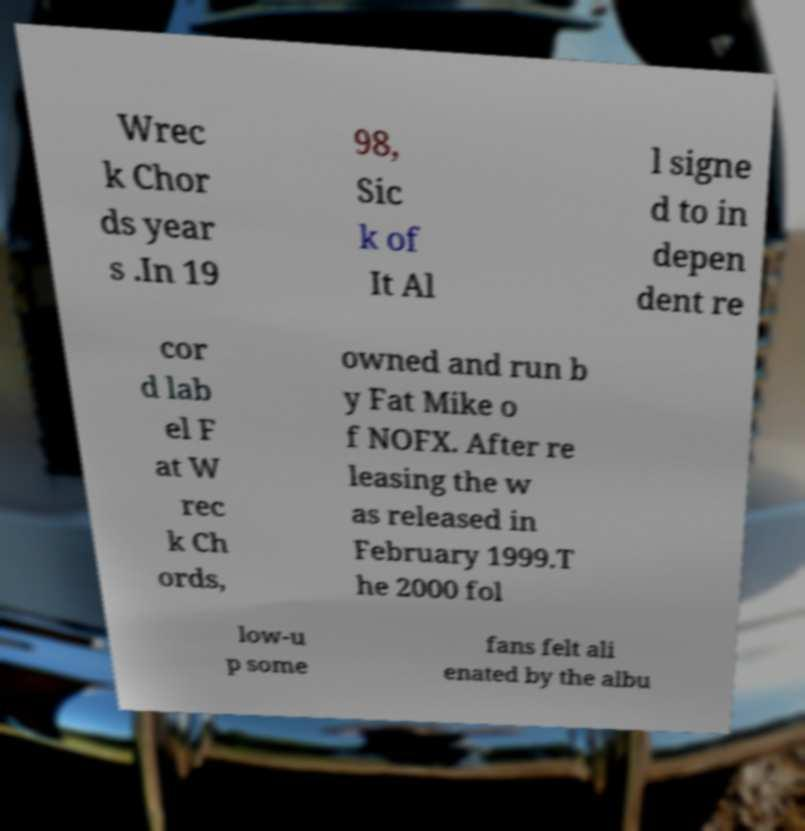Please identify and transcribe the text found in this image. Wrec k Chor ds year s .In 19 98, Sic k of It Al l signe d to in depen dent re cor d lab el F at W rec k Ch ords, owned and run b y Fat Mike o f NOFX. After re leasing the w as released in February 1999.T he 2000 fol low-u p some fans felt ali enated by the albu 